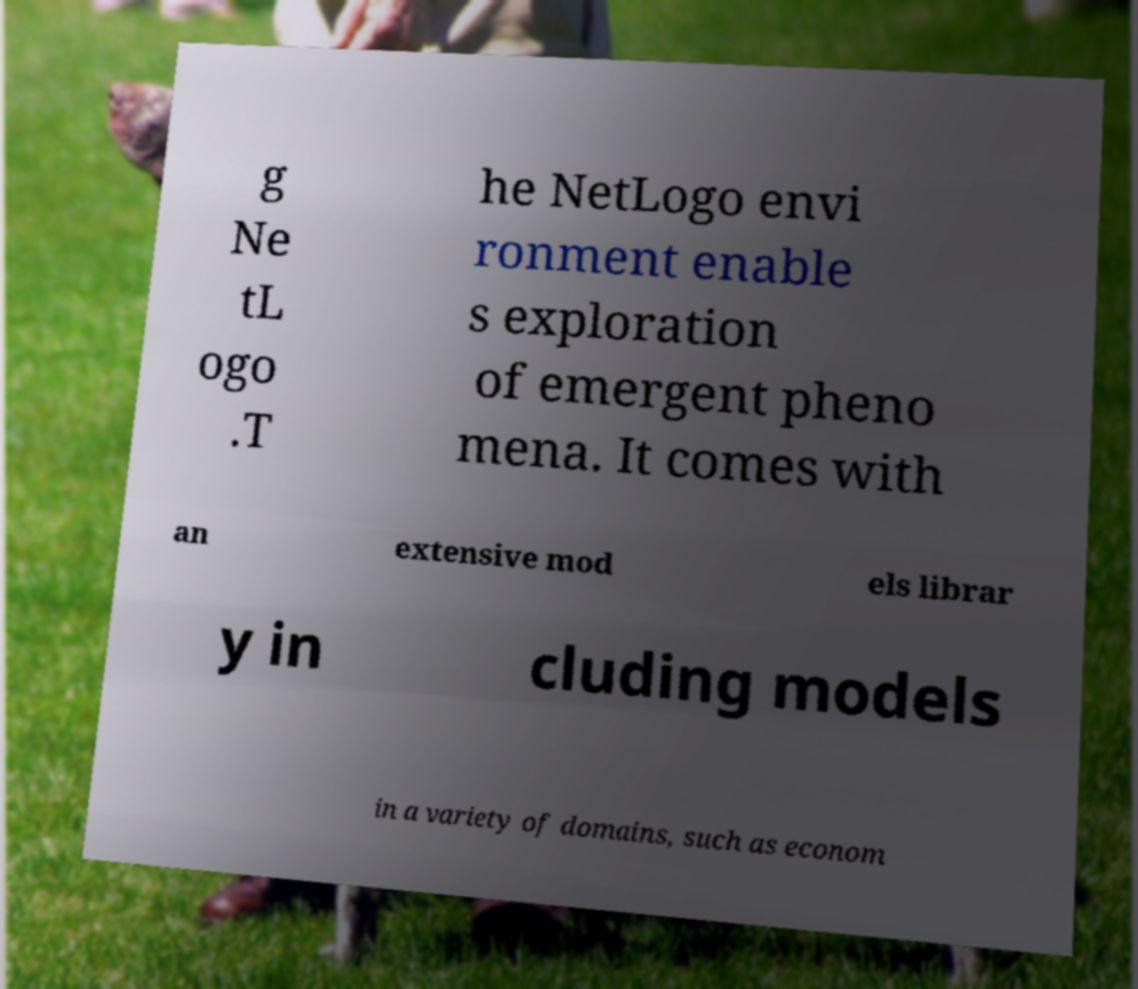There's text embedded in this image that I need extracted. Can you transcribe it verbatim? g Ne tL ogo .T he NetLogo envi ronment enable s exploration of emergent pheno mena. It comes with an extensive mod els librar y in cluding models in a variety of domains, such as econom 